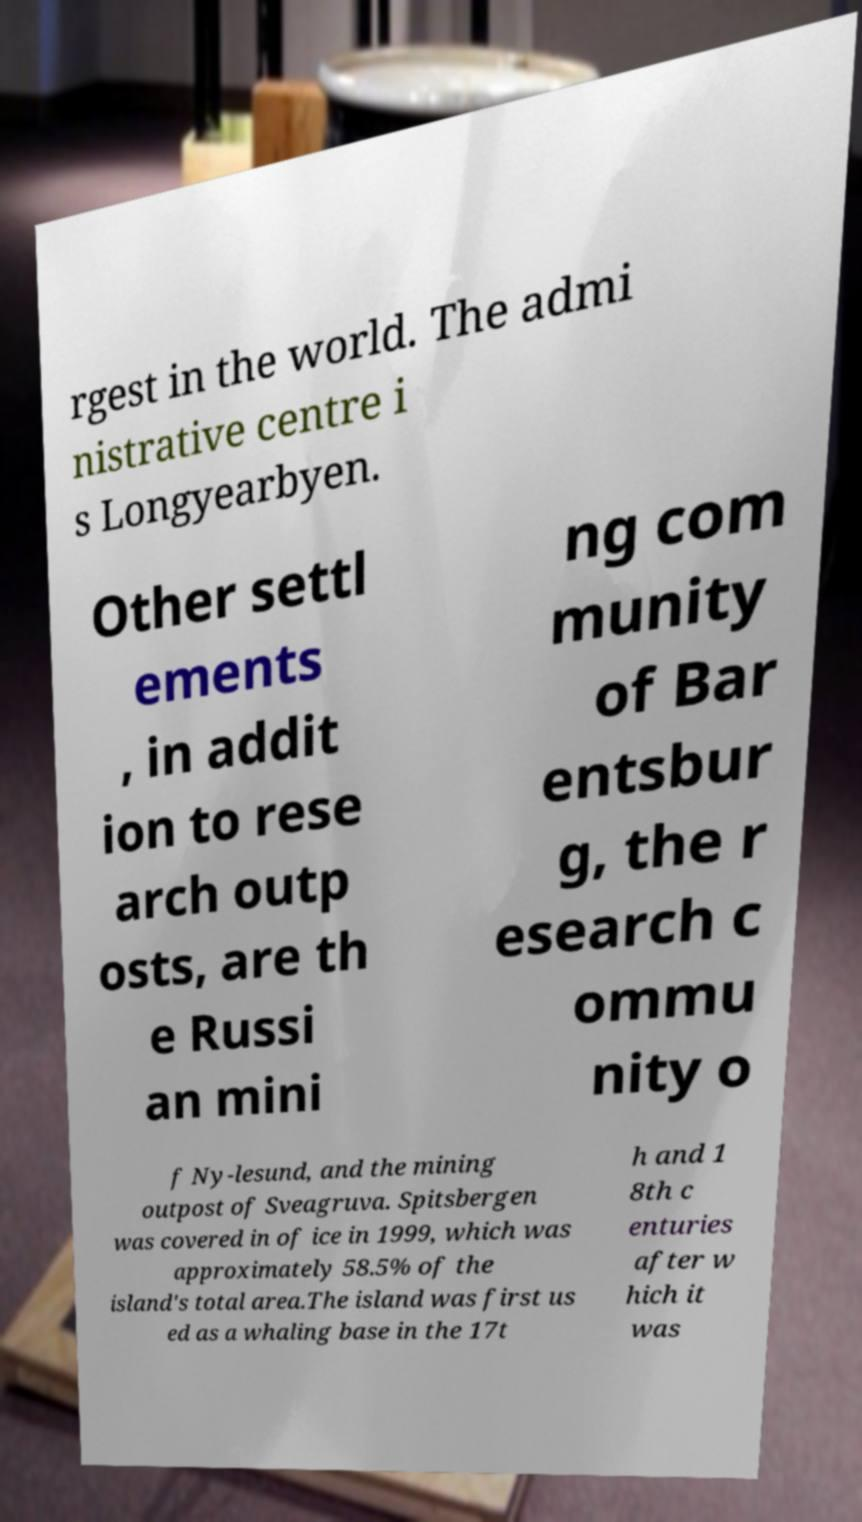Can you read and provide the text displayed in the image?This photo seems to have some interesting text. Can you extract and type it out for me? rgest in the world. The admi nistrative centre i s Longyearbyen. Other settl ements , in addit ion to rese arch outp osts, are th e Russi an mini ng com munity of Bar entsbur g, the r esearch c ommu nity o f Ny-lesund, and the mining outpost of Sveagruva. Spitsbergen was covered in of ice in 1999, which was approximately 58.5% of the island's total area.The island was first us ed as a whaling base in the 17t h and 1 8th c enturies after w hich it was 